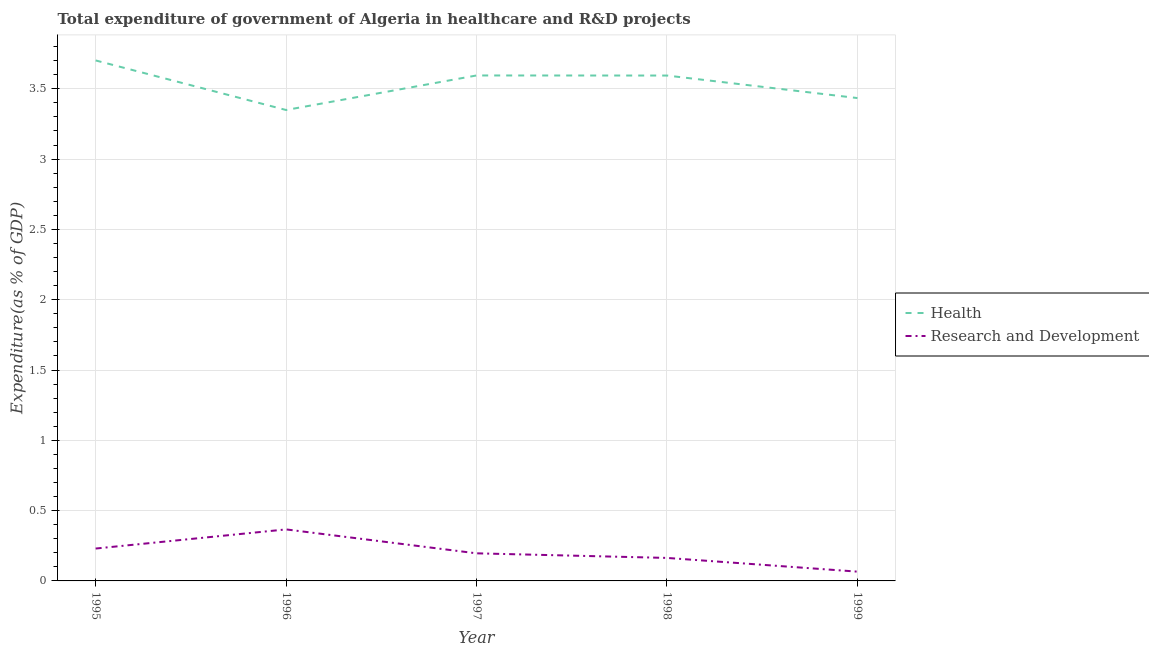Does the line corresponding to expenditure in healthcare intersect with the line corresponding to expenditure in r&d?
Your response must be concise. No. Is the number of lines equal to the number of legend labels?
Offer a very short reply. Yes. What is the expenditure in r&d in 1995?
Provide a succinct answer. 0.23. Across all years, what is the maximum expenditure in r&d?
Provide a short and direct response. 0.37. Across all years, what is the minimum expenditure in healthcare?
Provide a succinct answer. 3.35. In which year was the expenditure in healthcare maximum?
Ensure brevity in your answer.  1995. In which year was the expenditure in r&d minimum?
Provide a succinct answer. 1999. What is the total expenditure in r&d in the graph?
Offer a terse response. 1.02. What is the difference between the expenditure in healthcare in 1995 and that in 1997?
Your answer should be compact. 0.11. What is the difference between the expenditure in r&d in 1997 and the expenditure in healthcare in 1998?
Offer a terse response. -3.4. What is the average expenditure in r&d per year?
Make the answer very short. 0.2. In the year 1996, what is the difference between the expenditure in r&d and expenditure in healthcare?
Your response must be concise. -2.98. In how many years, is the expenditure in r&d greater than 2 %?
Make the answer very short. 0. What is the ratio of the expenditure in r&d in 1998 to that in 1999?
Your answer should be compact. 2.48. What is the difference between the highest and the second highest expenditure in healthcare?
Your response must be concise. 0.11. What is the difference between the highest and the lowest expenditure in healthcare?
Offer a very short reply. 0.35. In how many years, is the expenditure in r&d greater than the average expenditure in r&d taken over all years?
Keep it short and to the point. 2. Is the sum of the expenditure in healthcare in 1995 and 1998 greater than the maximum expenditure in r&d across all years?
Give a very brief answer. Yes. Does the expenditure in healthcare monotonically increase over the years?
Keep it short and to the point. No. Is the expenditure in r&d strictly greater than the expenditure in healthcare over the years?
Provide a succinct answer. No. Is the expenditure in r&d strictly less than the expenditure in healthcare over the years?
Your answer should be very brief. Yes. How many lines are there?
Offer a terse response. 2. How many years are there in the graph?
Offer a very short reply. 5. What is the difference between two consecutive major ticks on the Y-axis?
Offer a very short reply. 0.5. Are the values on the major ticks of Y-axis written in scientific E-notation?
Ensure brevity in your answer.  No. Does the graph contain grids?
Your answer should be very brief. Yes. What is the title of the graph?
Make the answer very short. Total expenditure of government of Algeria in healthcare and R&D projects. Does "Grants" appear as one of the legend labels in the graph?
Offer a very short reply. No. What is the label or title of the Y-axis?
Your answer should be compact. Expenditure(as % of GDP). What is the Expenditure(as % of GDP) in Health in 1995?
Provide a succinct answer. 3.7. What is the Expenditure(as % of GDP) of Research and Development in 1995?
Offer a terse response. 0.23. What is the Expenditure(as % of GDP) in Health in 1996?
Your answer should be compact. 3.35. What is the Expenditure(as % of GDP) of Research and Development in 1996?
Your answer should be very brief. 0.37. What is the Expenditure(as % of GDP) in Health in 1997?
Make the answer very short. 3.59. What is the Expenditure(as % of GDP) of Research and Development in 1997?
Give a very brief answer. 0.2. What is the Expenditure(as % of GDP) of Health in 1998?
Ensure brevity in your answer.  3.59. What is the Expenditure(as % of GDP) of Research and Development in 1998?
Make the answer very short. 0.16. What is the Expenditure(as % of GDP) in Health in 1999?
Your response must be concise. 3.43. What is the Expenditure(as % of GDP) of Research and Development in 1999?
Your response must be concise. 0.07. Across all years, what is the maximum Expenditure(as % of GDP) of Health?
Keep it short and to the point. 3.7. Across all years, what is the maximum Expenditure(as % of GDP) in Research and Development?
Give a very brief answer. 0.37. Across all years, what is the minimum Expenditure(as % of GDP) of Health?
Make the answer very short. 3.35. Across all years, what is the minimum Expenditure(as % of GDP) in Research and Development?
Your response must be concise. 0.07. What is the total Expenditure(as % of GDP) in Health in the graph?
Offer a terse response. 17.67. What is the total Expenditure(as % of GDP) of Research and Development in the graph?
Provide a short and direct response. 1.02. What is the difference between the Expenditure(as % of GDP) of Health in 1995 and that in 1996?
Make the answer very short. 0.35. What is the difference between the Expenditure(as % of GDP) of Research and Development in 1995 and that in 1996?
Your answer should be compact. -0.14. What is the difference between the Expenditure(as % of GDP) in Health in 1995 and that in 1997?
Keep it short and to the point. 0.11. What is the difference between the Expenditure(as % of GDP) in Research and Development in 1995 and that in 1997?
Offer a terse response. 0.03. What is the difference between the Expenditure(as % of GDP) of Health in 1995 and that in 1998?
Offer a terse response. 0.11. What is the difference between the Expenditure(as % of GDP) in Research and Development in 1995 and that in 1998?
Keep it short and to the point. 0.07. What is the difference between the Expenditure(as % of GDP) of Health in 1995 and that in 1999?
Provide a short and direct response. 0.27. What is the difference between the Expenditure(as % of GDP) of Research and Development in 1995 and that in 1999?
Provide a succinct answer. 0.16. What is the difference between the Expenditure(as % of GDP) of Health in 1996 and that in 1997?
Give a very brief answer. -0.25. What is the difference between the Expenditure(as % of GDP) in Research and Development in 1996 and that in 1997?
Keep it short and to the point. 0.17. What is the difference between the Expenditure(as % of GDP) in Health in 1996 and that in 1998?
Provide a short and direct response. -0.24. What is the difference between the Expenditure(as % of GDP) in Research and Development in 1996 and that in 1998?
Make the answer very short. 0.2. What is the difference between the Expenditure(as % of GDP) of Health in 1996 and that in 1999?
Offer a very short reply. -0.08. What is the difference between the Expenditure(as % of GDP) of Research and Development in 1996 and that in 1999?
Your response must be concise. 0.3. What is the difference between the Expenditure(as % of GDP) of Health in 1997 and that in 1998?
Offer a very short reply. 0. What is the difference between the Expenditure(as % of GDP) of Research and Development in 1997 and that in 1998?
Your answer should be compact. 0.03. What is the difference between the Expenditure(as % of GDP) of Health in 1997 and that in 1999?
Keep it short and to the point. 0.16. What is the difference between the Expenditure(as % of GDP) in Research and Development in 1997 and that in 1999?
Make the answer very short. 0.13. What is the difference between the Expenditure(as % of GDP) in Health in 1998 and that in 1999?
Ensure brevity in your answer.  0.16. What is the difference between the Expenditure(as % of GDP) of Research and Development in 1998 and that in 1999?
Your answer should be very brief. 0.1. What is the difference between the Expenditure(as % of GDP) of Health in 1995 and the Expenditure(as % of GDP) of Research and Development in 1996?
Ensure brevity in your answer.  3.34. What is the difference between the Expenditure(as % of GDP) in Health in 1995 and the Expenditure(as % of GDP) in Research and Development in 1997?
Give a very brief answer. 3.51. What is the difference between the Expenditure(as % of GDP) in Health in 1995 and the Expenditure(as % of GDP) in Research and Development in 1998?
Ensure brevity in your answer.  3.54. What is the difference between the Expenditure(as % of GDP) in Health in 1995 and the Expenditure(as % of GDP) in Research and Development in 1999?
Provide a short and direct response. 3.64. What is the difference between the Expenditure(as % of GDP) of Health in 1996 and the Expenditure(as % of GDP) of Research and Development in 1997?
Offer a very short reply. 3.15. What is the difference between the Expenditure(as % of GDP) of Health in 1996 and the Expenditure(as % of GDP) of Research and Development in 1998?
Make the answer very short. 3.19. What is the difference between the Expenditure(as % of GDP) in Health in 1996 and the Expenditure(as % of GDP) in Research and Development in 1999?
Provide a short and direct response. 3.28. What is the difference between the Expenditure(as % of GDP) in Health in 1997 and the Expenditure(as % of GDP) in Research and Development in 1998?
Provide a short and direct response. 3.43. What is the difference between the Expenditure(as % of GDP) in Health in 1997 and the Expenditure(as % of GDP) in Research and Development in 1999?
Your answer should be compact. 3.53. What is the difference between the Expenditure(as % of GDP) of Health in 1998 and the Expenditure(as % of GDP) of Research and Development in 1999?
Keep it short and to the point. 3.53. What is the average Expenditure(as % of GDP) in Health per year?
Ensure brevity in your answer.  3.53. What is the average Expenditure(as % of GDP) in Research and Development per year?
Provide a short and direct response. 0.2. In the year 1995, what is the difference between the Expenditure(as % of GDP) in Health and Expenditure(as % of GDP) in Research and Development?
Your answer should be compact. 3.47. In the year 1996, what is the difference between the Expenditure(as % of GDP) in Health and Expenditure(as % of GDP) in Research and Development?
Your answer should be compact. 2.98. In the year 1997, what is the difference between the Expenditure(as % of GDP) of Health and Expenditure(as % of GDP) of Research and Development?
Your answer should be compact. 3.4. In the year 1998, what is the difference between the Expenditure(as % of GDP) in Health and Expenditure(as % of GDP) in Research and Development?
Keep it short and to the point. 3.43. In the year 1999, what is the difference between the Expenditure(as % of GDP) in Health and Expenditure(as % of GDP) in Research and Development?
Provide a succinct answer. 3.37. What is the ratio of the Expenditure(as % of GDP) of Health in 1995 to that in 1996?
Your answer should be very brief. 1.11. What is the ratio of the Expenditure(as % of GDP) of Research and Development in 1995 to that in 1996?
Give a very brief answer. 0.63. What is the ratio of the Expenditure(as % of GDP) in Health in 1995 to that in 1997?
Give a very brief answer. 1.03. What is the ratio of the Expenditure(as % of GDP) of Research and Development in 1995 to that in 1997?
Keep it short and to the point. 1.17. What is the ratio of the Expenditure(as % of GDP) in Health in 1995 to that in 1998?
Provide a succinct answer. 1.03. What is the ratio of the Expenditure(as % of GDP) of Research and Development in 1995 to that in 1998?
Ensure brevity in your answer.  1.41. What is the ratio of the Expenditure(as % of GDP) of Health in 1995 to that in 1999?
Your answer should be compact. 1.08. What is the ratio of the Expenditure(as % of GDP) in Research and Development in 1995 to that in 1999?
Keep it short and to the point. 3.49. What is the ratio of the Expenditure(as % of GDP) of Health in 1996 to that in 1997?
Ensure brevity in your answer.  0.93. What is the ratio of the Expenditure(as % of GDP) in Research and Development in 1996 to that in 1997?
Give a very brief answer. 1.87. What is the ratio of the Expenditure(as % of GDP) in Health in 1996 to that in 1998?
Offer a very short reply. 0.93. What is the ratio of the Expenditure(as % of GDP) in Research and Development in 1996 to that in 1998?
Offer a terse response. 2.24. What is the ratio of the Expenditure(as % of GDP) in Health in 1996 to that in 1999?
Give a very brief answer. 0.98. What is the ratio of the Expenditure(as % of GDP) of Research and Development in 1996 to that in 1999?
Give a very brief answer. 5.55. What is the ratio of the Expenditure(as % of GDP) in Research and Development in 1997 to that in 1998?
Provide a succinct answer. 1.2. What is the ratio of the Expenditure(as % of GDP) of Health in 1997 to that in 1999?
Keep it short and to the point. 1.05. What is the ratio of the Expenditure(as % of GDP) of Research and Development in 1997 to that in 1999?
Your answer should be very brief. 2.97. What is the ratio of the Expenditure(as % of GDP) in Health in 1998 to that in 1999?
Make the answer very short. 1.05. What is the ratio of the Expenditure(as % of GDP) of Research and Development in 1998 to that in 1999?
Keep it short and to the point. 2.48. What is the difference between the highest and the second highest Expenditure(as % of GDP) of Health?
Keep it short and to the point. 0.11. What is the difference between the highest and the second highest Expenditure(as % of GDP) in Research and Development?
Keep it short and to the point. 0.14. What is the difference between the highest and the lowest Expenditure(as % of GDP) in Health?
Your answer should be very brief. 0.35. What is the difference between the highest and the lowest Expenditure(as % of GDP) of Research and Development?
Offer a terse response. 0.3. 